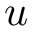Convert formula to latex. <formula><loc_0><loc_0><loc_500><loc_500>u</formula> 